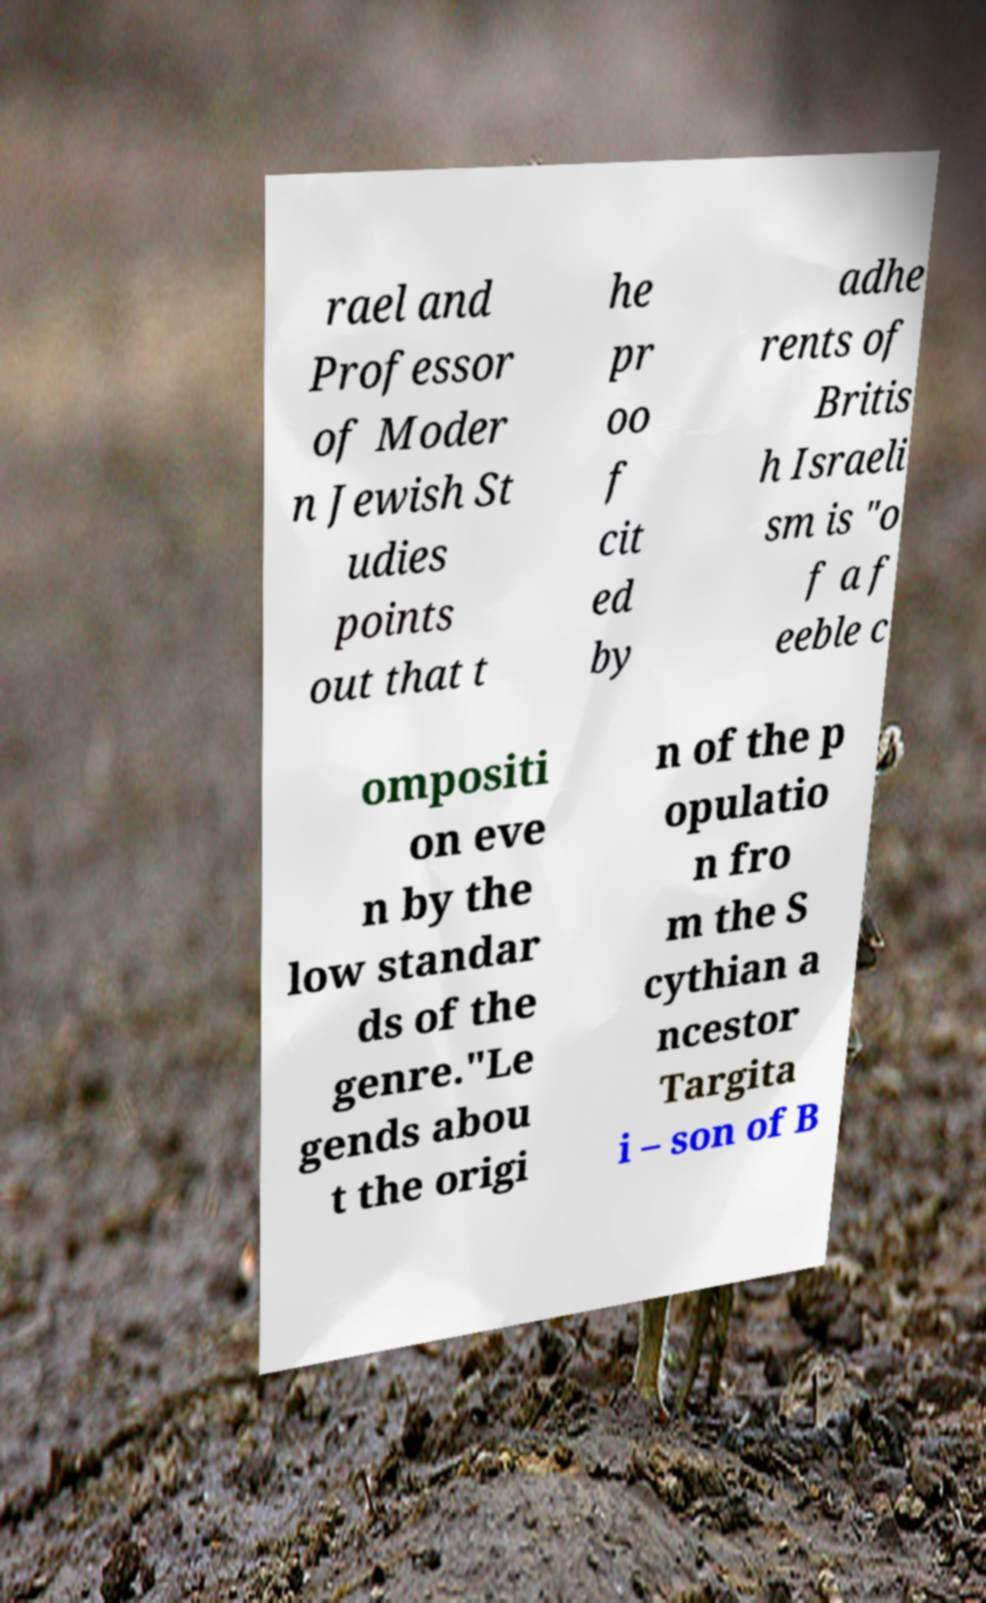Could you assist in decoding the text presented in this image and type it out clearly? rael and Professor of Moder n Jewish St udies points out that t he pr oo f cit ed by adhe rents of Britis h Israeli sm is "o f a f eeble c ompositi on eve n by the low standar ds of the genre."Le gends abou t the origi n of the p opulatio n fro m the S cythian a ncestor Targita i – son of B 